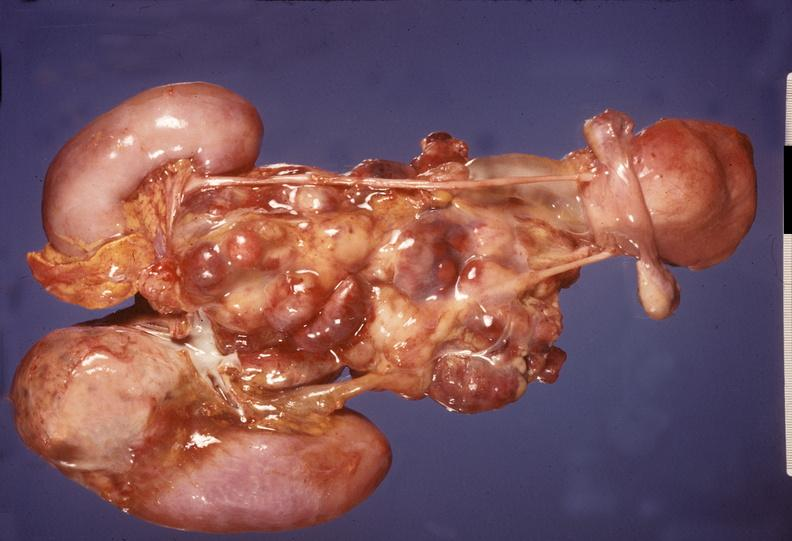s aldehyde fuscin present?
Answer the question using a single word or phrase. No 